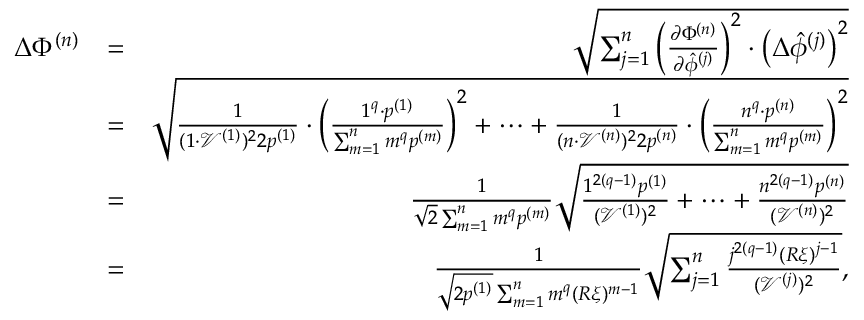Convert formula to latex. <formula><loc_0><loc_0><loc_500><loc_500>\begin{array} { r l r } { \Delta \Phi ^ { ( n ) } } & { = } & { \sqrt { \sum _ { j = 1 } ^ { n } \left ( \frac { \partial \Phi ^ { ( n ) } } { \partial \hat { \phi } ^ { ( j ) } } \right ) ^ { 2 } \cdot \left ( \Delta \hat { \phi } ^ { ( j ) } \right ) ^ { 2 } } } \\ & { = } & { \sqrt { \frac { 1 } { ( 1 \cdot \mathcal { V } ^ { ( 1 ) } ) ^ { 2 } 2 p ^ { ( 1 ) } } \cdot \left ( \frac { 1 ^ { q } \cdot p ^ { ( 1 ) } } { \sum _ { m = 1 } ^ { n } m ^ { q } p ^ { ( m ) } } \right ) ^ { 2 } + \cdots + \frac { 1 } { ( n \cdot \mathcal { V } ^ { ( n ) } ) ^ { 2 } 2 p ^ { ( n ) } } \cdot \left ( \frac { n ^ { q } \cdot p ^ { ( n ) } } { \sum _ { m = 1 } ^ { n } m ^ { q } p ^ { ( m ) } } \right ) ^ { 2 } } } \\ & { = } & { \frac { 1 } { \sqrt { 2 } \sum _ { m = 1 } ^ { n } m ^ { q } p ^ { ( m ) } } \sqrt { \frac { 1 ^ { 2 ( q - 1 ) } p ^ { ( 1 ) } } { ( \mathcal { V } ^ { ( 1 ) } ) ^ { 2 } } + \cdots + \frac { n ^ { 2 ( q - 1 ) } p ^ { ( n ) } } { ( \mathcal { V } ^ { ( n ) } ) ^ { 2 } } } } \\ & { = } & { \frac { 1 } { \sqrt { 2 p ^ { ( 1 ) } } \sum _ { m = 1 } ^ { n } m ^ { q } ( R \xi ) ^ { m - 1 } } \sqrt { \sum _ { j = 1 } ^ { n } \frac { j ^ { 2 ( q - 1 ) } ( R \xi ) ^ { j - 1 } } { ( \mathcal { V } ^ { ( j ) } ) ^ { 2 } } } , } \end{array}</formula> 